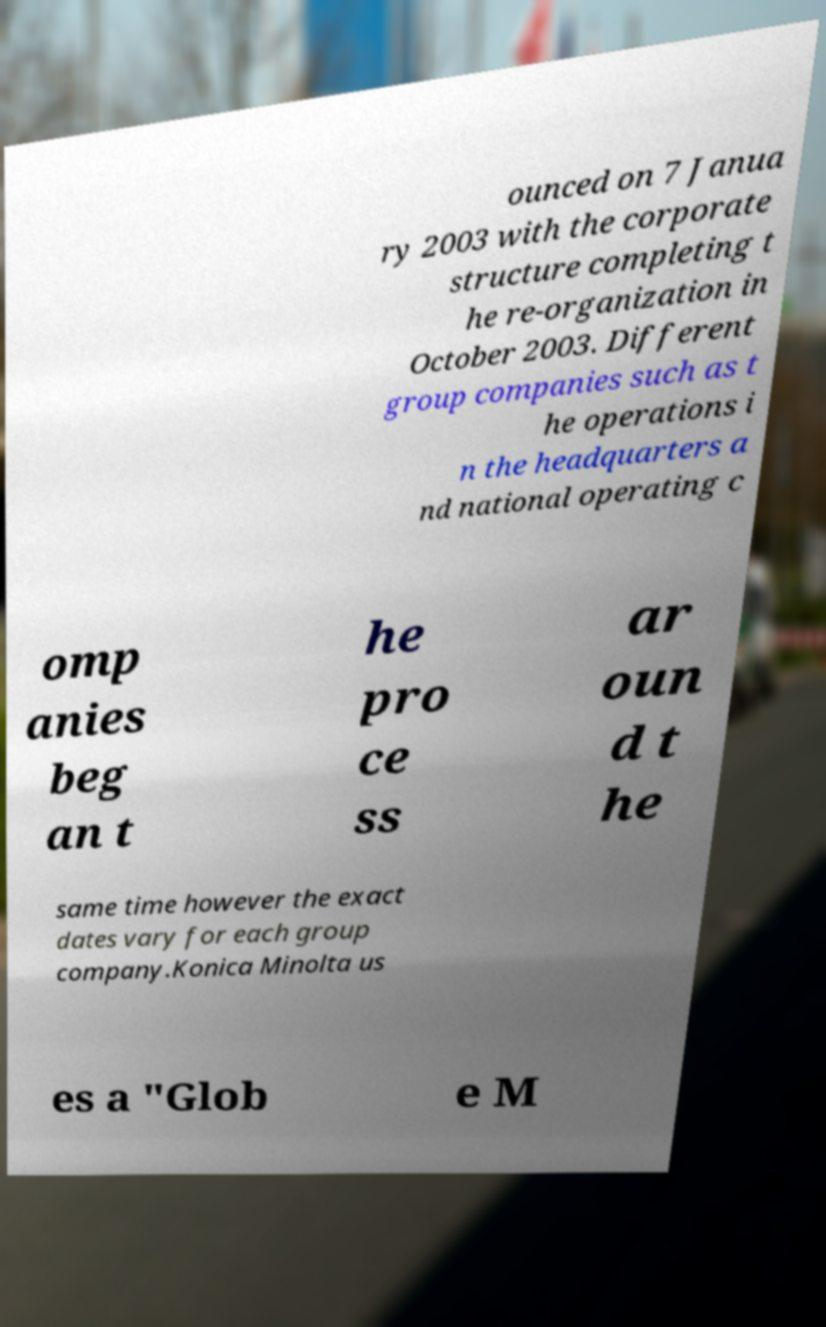I need the written content from this picture converted into text. Can you do that? ounced on 7 Janua ry 2003 with the corporate structure completing t he re-organization in October 2003. Different group companies such as t he operations i n the headquarters a nd national operating c omp anies beg an t he pro ce ss ar oun d t he same time however the exact dates vary for each group company.Konica Minolta us es a "Glob e M 